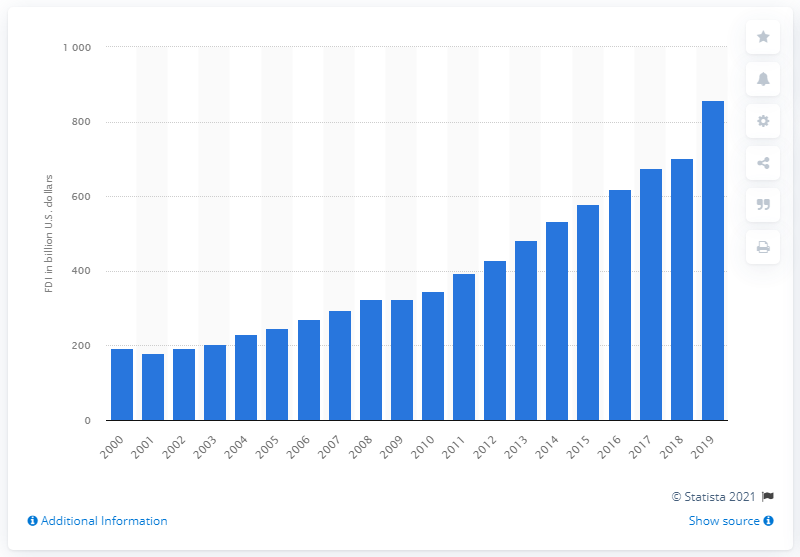Outline some significant characteristics in this image. In 2019, the total amount of foreign direct investments from the Asia Pacific region in the United States was 858.53. 